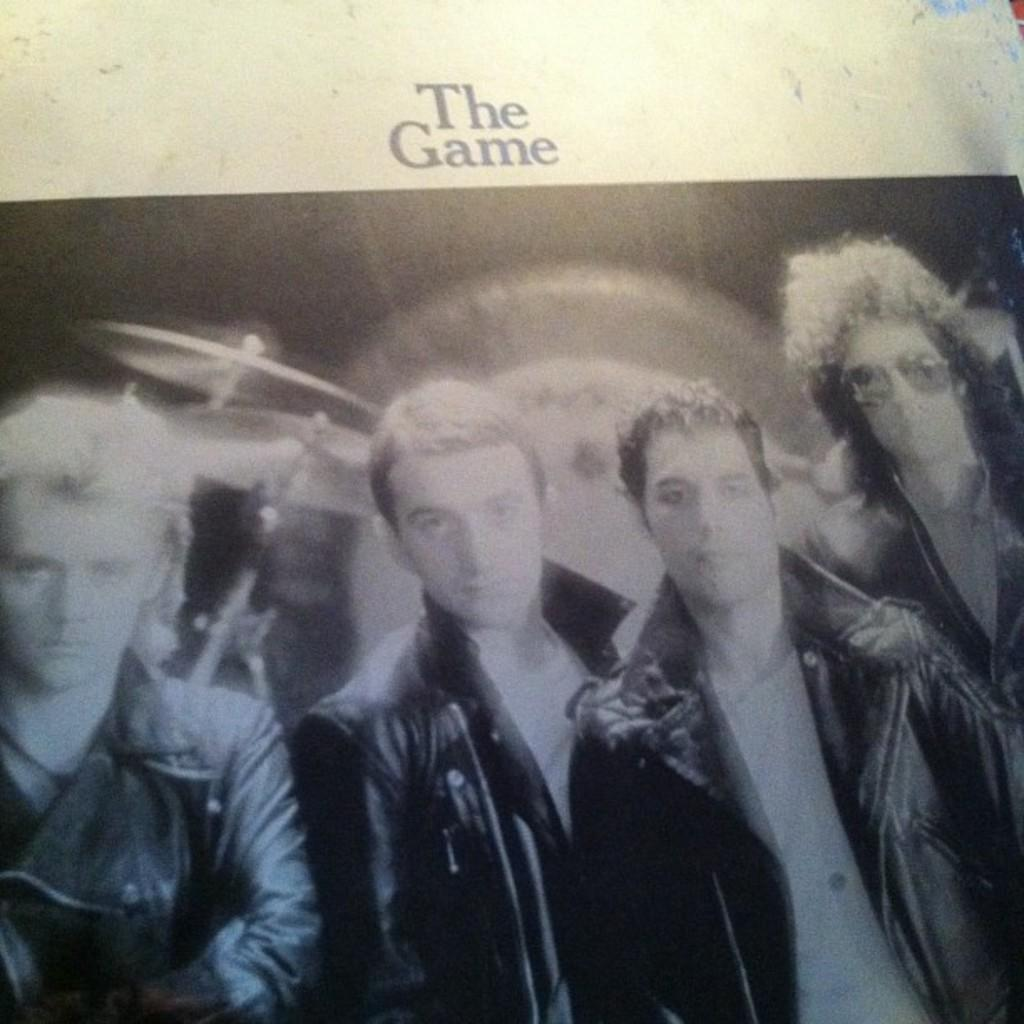What is the main subject of the card in the image? The card has images of four people wearing jackets. What is happening behind the people in the image? There is an orchestra visible behind the people. What phrase is present at the top of the card? The phrase "the game" is present at the top of the card. What type of cloth is draped over the rabbit in the image? There is no rabbit present in the image. 